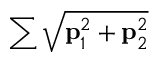<formula> <loc_0><loc_0><loc_500><loc_500>\sum \sqrt { p _ { 1 } ^ { 2 } + p _ { 2 } ^ { 2 } }</formula> 